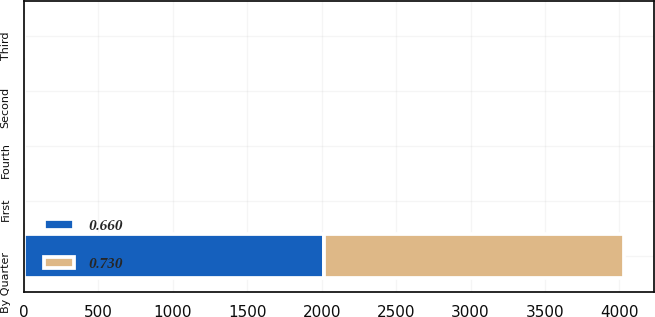<chart> <loc_0><loc_0><loc_500><loc_500><stacked_bar_chart><ecel><fcel>By Quarter<fcel>First<fcel>Second<fcel>Third<fcel>Fourth<nl><fcel>0.73<fcel>2016<fcel>0.66<fcel>0.66<fcel>0.66<fcel>0.66<nl><fcel>0.66<fcel>2017<fcel>0.73<fcel>0.73<fcel>0.73<fcel>0.73<nl></chart> 